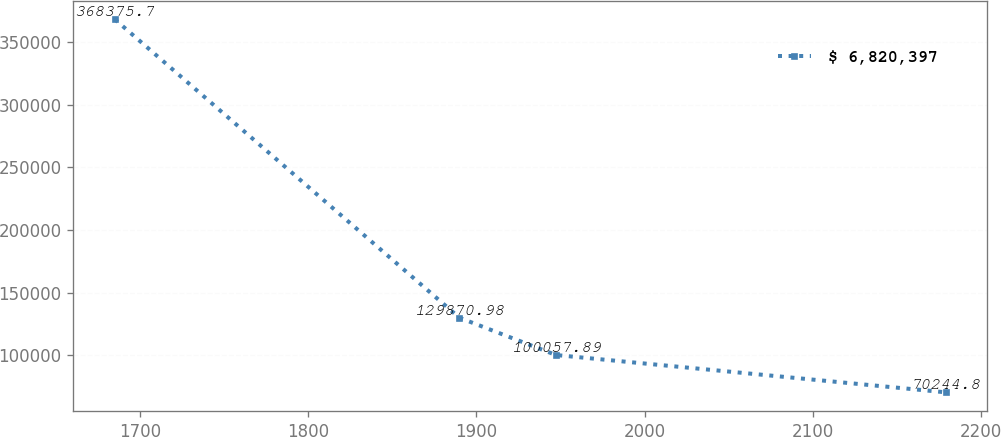Convert chart to OTSL. <chart><loc_0><loc_0><loc_500><loc_500><line_chart><ecel><fcel>$ 6,820,397<nl><fcel>1685.05<fcel>368376<nl><fcel>1889.92<fcel>129871<nl><fcel>1947.34<fcel>100058<nl><fcel>2179.01<fcel>70244.8<nl></chart> 